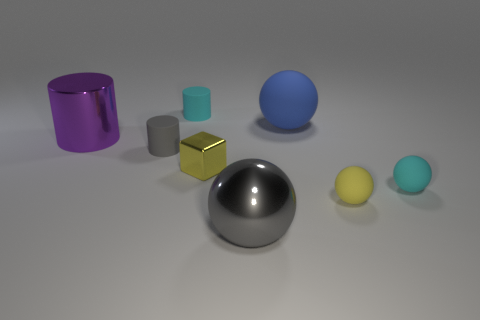Subtract all purple cylinders. How many cylinders are left? 2 Subtract all gray balls. How many balls are left? 3 Add 1 small metal spheres. How many objects exist? 9 Subtract all brown cylinders. Subtract all green spheres. How many cylinders are left? 3 Subtract all blocks. How many objects are left? 7 Add 2 small yellow rubber spheres. How many small yellow rubber spheres are left? 3 Add 5 brown matte cylinders. How many brown matte cylinders exist? 5 Subtract 0 cyan blocks. How many objects are left? 8 Subtract all big blue things. Subtract all tiny yellow shiny cubes. How many objects are left? 6 